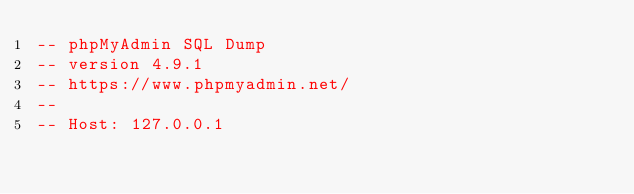Convert code to text. <code><loc_0><loc_0><loc_500><loc_500><_SQL_>-- phpMyAdmin SQL Dump
-- version 4.9.1
-- https://www.phpmyadmin.net/
--
-- Host: 127.0.0.1</code> 